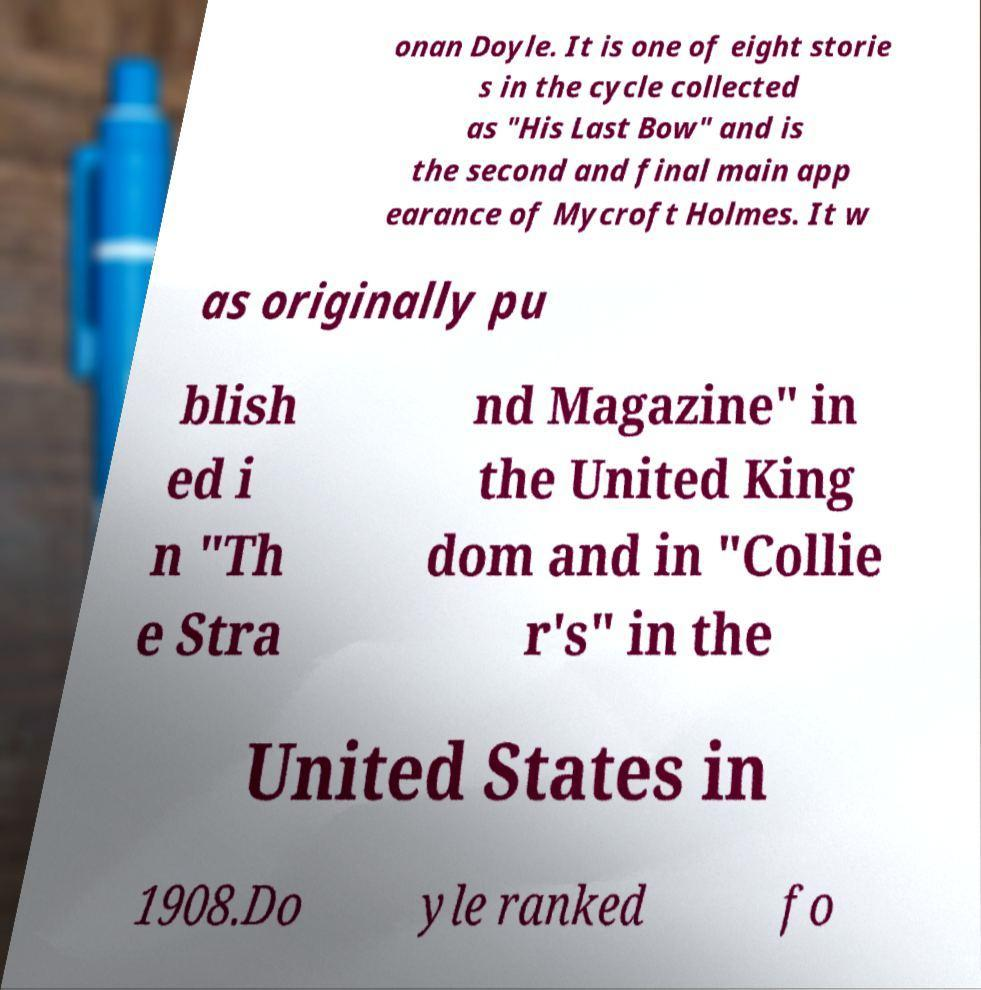Please identify and transcribe the text found in this image. onan Doyle. It is one of eight storie s in the cycle collected as "His Last Bow" and is the second and final main app earance of Mycroft Holmes. It w as originally pu blish ed i n "Th e Stra nd Magazine" in the United King dom and in "Collie r's" in the United States in 1908.Do yle ranked fo 